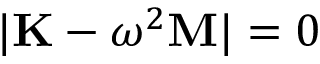Convert formula to latex. <formula><loc_0><loc_0><loc_500><loc_500>| K - \omega ^ { 2 } M | = 0</formula> 